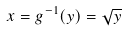<formula> <loc_0><loc_0><loc_500><loc_500>x = g ^ { - 1 } ( y ) = \sqrt { y }</formula> 